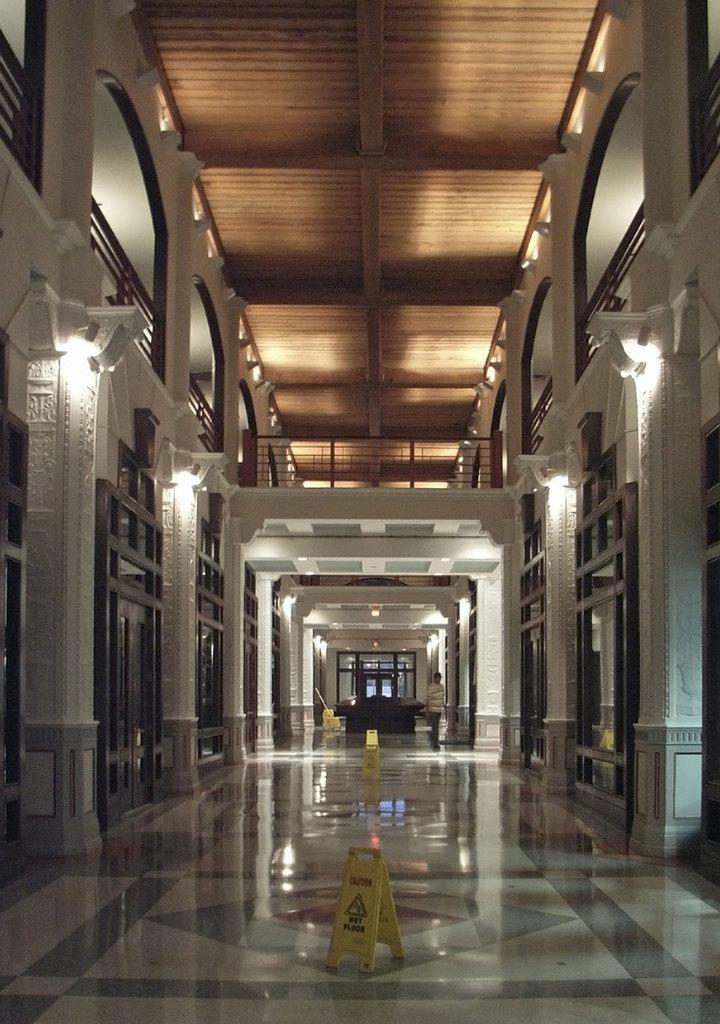How would you summarize this image in a sentence or two? In this picture I can see inner view of a building, a human standing and couple of caution boards on the floor and I can see few lights. 